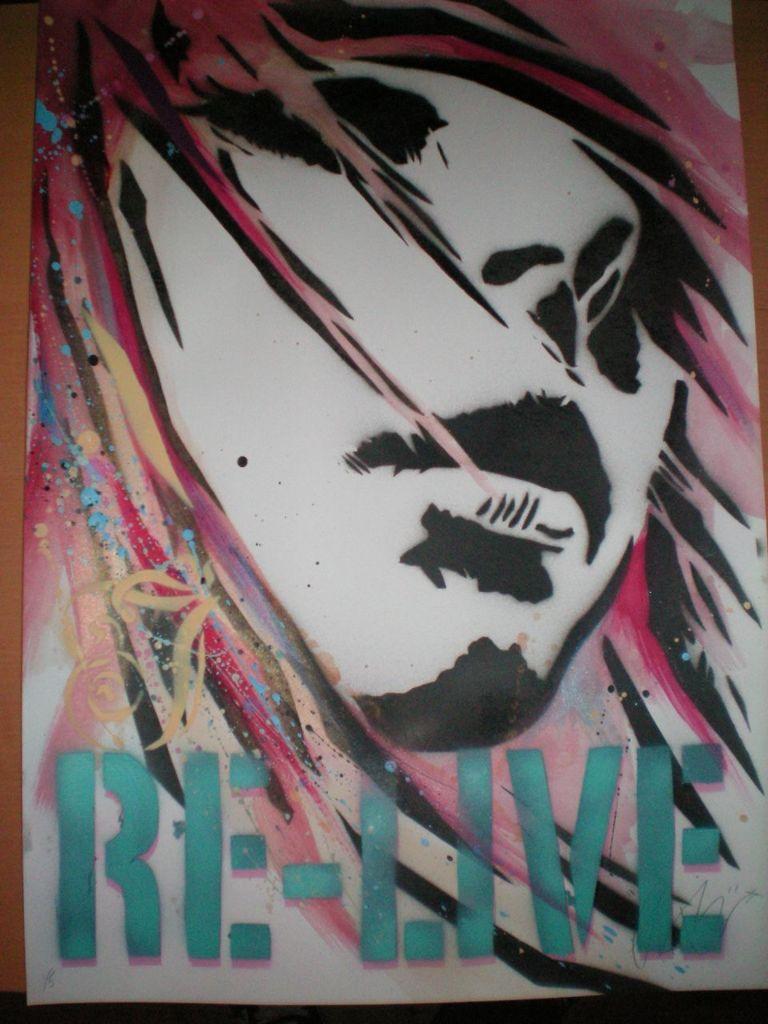Please provide a concise description of this image. In this picture there is a drawing poster of the girl. On the bottom side there is a small quote written on it. 